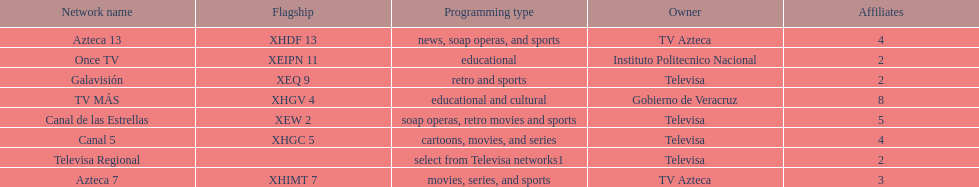Name each of tv azteca's network names. Azteca 7, Azteca 13. 